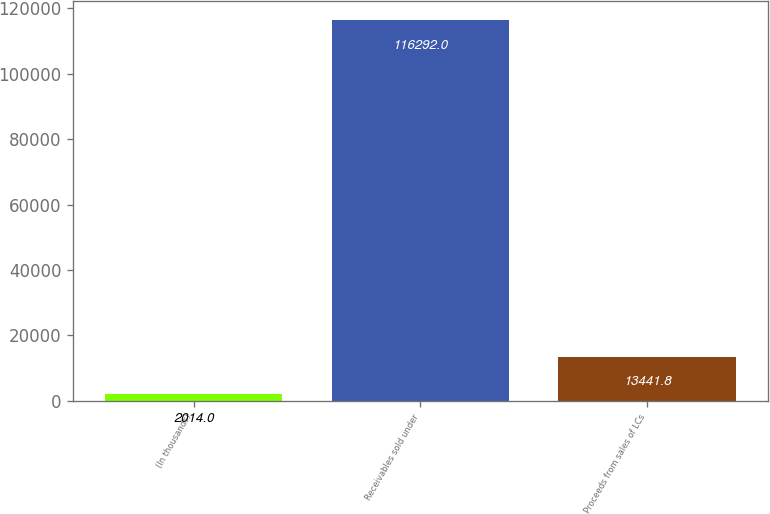<chart> <loc_0><loc_0><loc_500><loc_500><bar_chart><fcel>(In thousands)<fcel>Receivables sold under<fcel>Proceeds from sales of LCs<nl><fcel>2014<fcel>116292<fcel>13441.8<nl></chart> 